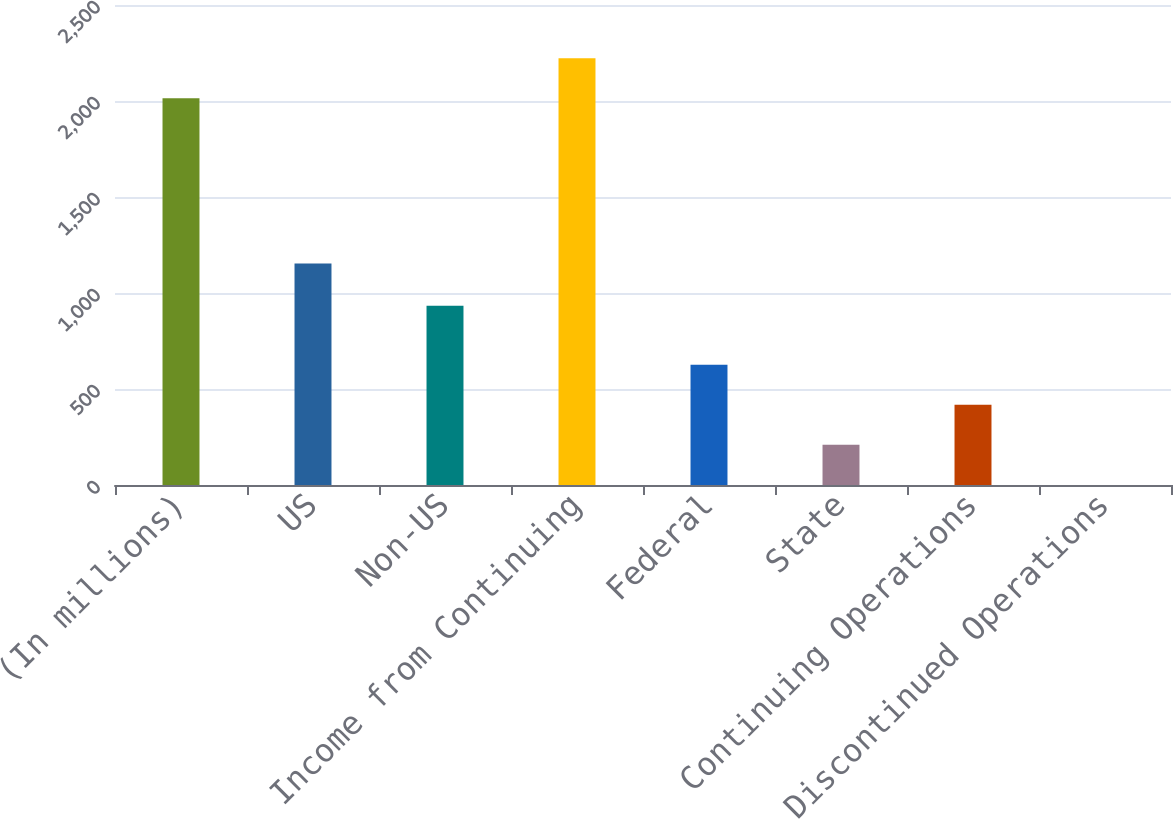Convert chart to OTSL. <chart><loc_0><loc_0><loc_500><loc_500><bar_chart><fcel>(In millions)<fcel>US<fcel>Non-US<fcel>Income from Continuing<fcel>Federal<fcel>State<fcel>Continuing Operations<fcel>Discontinued Operations<nl><fcel>2014<fcel>1153.3<fcel>933.9<fcel>2222.66<fcel>626.58<fcel>209.26<fcel>417.92<fcel>0.6<nl></chart> 